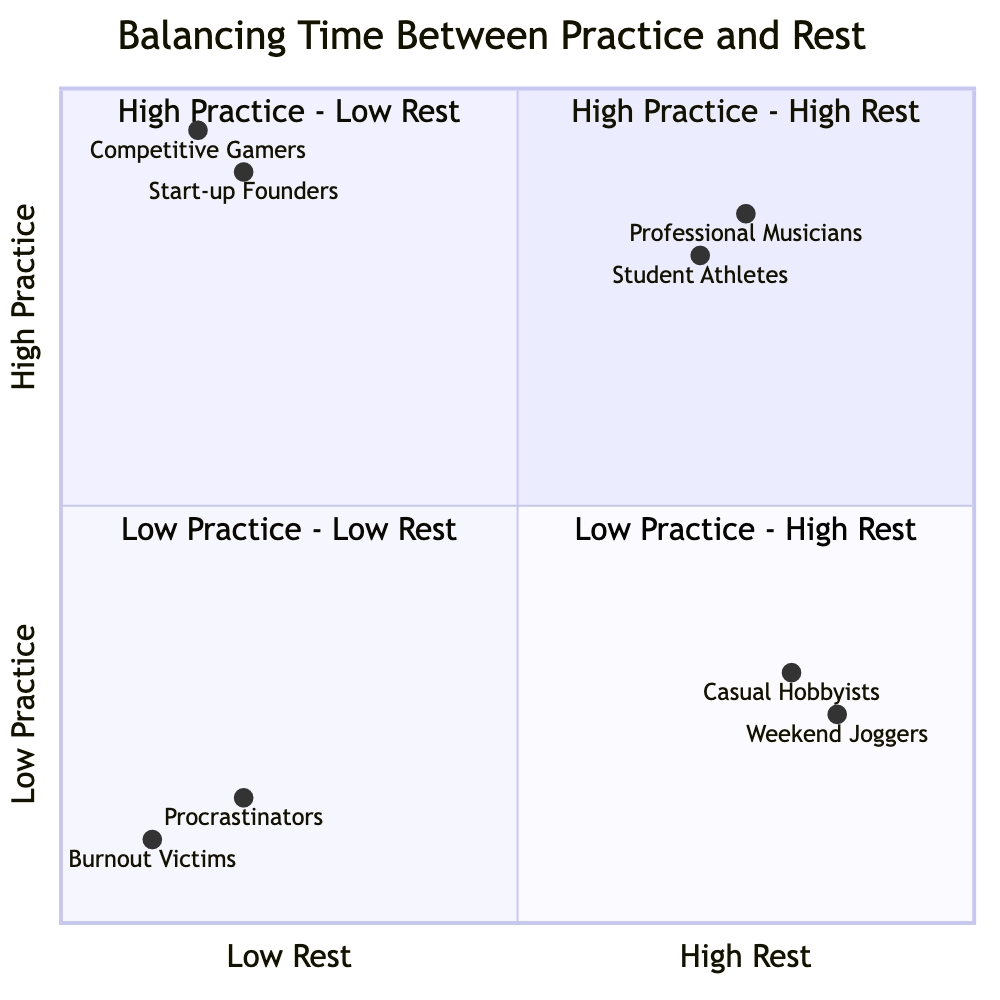What does the top right quadrant represent? The top right quadrant is labeled "High Practice - High Rest" which signifies a balanced approach where significant time is dedicated to both practice and rest.
Answer: High Practice - High Rest How many examples are listed in the "Low Practice - High Rest" quadrant? The "Low Practice - High Rest" quadrant is empty of specific examples in the data provided, indicating no specific groups are identified in this category.
Answer: 0 Which example is located in the "High Practice - Low Rest" quadrant? The example located in the "High Practice - Low Rest" quadrant is "Start-up Founders" as indicated in the examples listed for that quadrant.
Answer: Start-up Founders What is the characteristic of individuals in the "Low Practice - Low Rest" quadrant? Individuals in this quadrant are characterized by minimal practice and minimal rest, leading to stagnation and disengagement from the activity.
Answer: Stagnation Which group is closest to the origin (0,0) in the diagram? The group closest to the origin (0,0) is "Burnout Victims," which represents a situation of both low practice and low rest.
Answer: Burnout Victims What are the coordinates of "Professional Musicians"? "Professional Musicians" are located at coordinates (0.75, 0.85), which places them in the "High Practice - High Rest" quadrant.
Answer: (0.75, 0.85) What is the relationship between "Weekenders Joggers" and "Casual Hobbyists"? "Weekend Joggers" and "Casual Hobbyists" both fall into the "Low Practice - High Rest" quadrant, suggesting they have minimal practice but prioritize rest, which positions them similarly in the diagram.
Answer: Similar Which quadrant represents the highest risk of burnout? The "High Practice - Low Rest" quadrant represents the highest risk of burnout due to intense practice sessions with minimal rest.
Answer: High Practice - Low Rest How does the "Low Practice - High Rest" quadrant affect progress? The "Low Practice - High Rest" quadrant can lead to underachievement and slower progress due to minimal practice despite ample rest.
Answer: Underachievement 